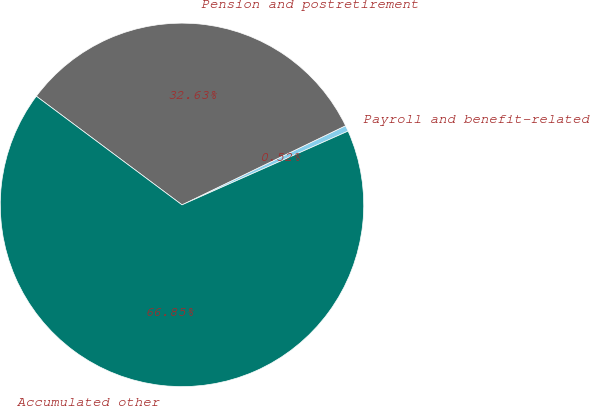Convert chart. <chart><loc_0><loc_0><loc_500><loc_500><pie_chart><fcel>Payroll and benefit-related<fcel>Pension and postretirement<fcel>Accumulated other<nl><fcel>0.52%<fcel>32.63%<fcel>66.85%<nl></chart> 